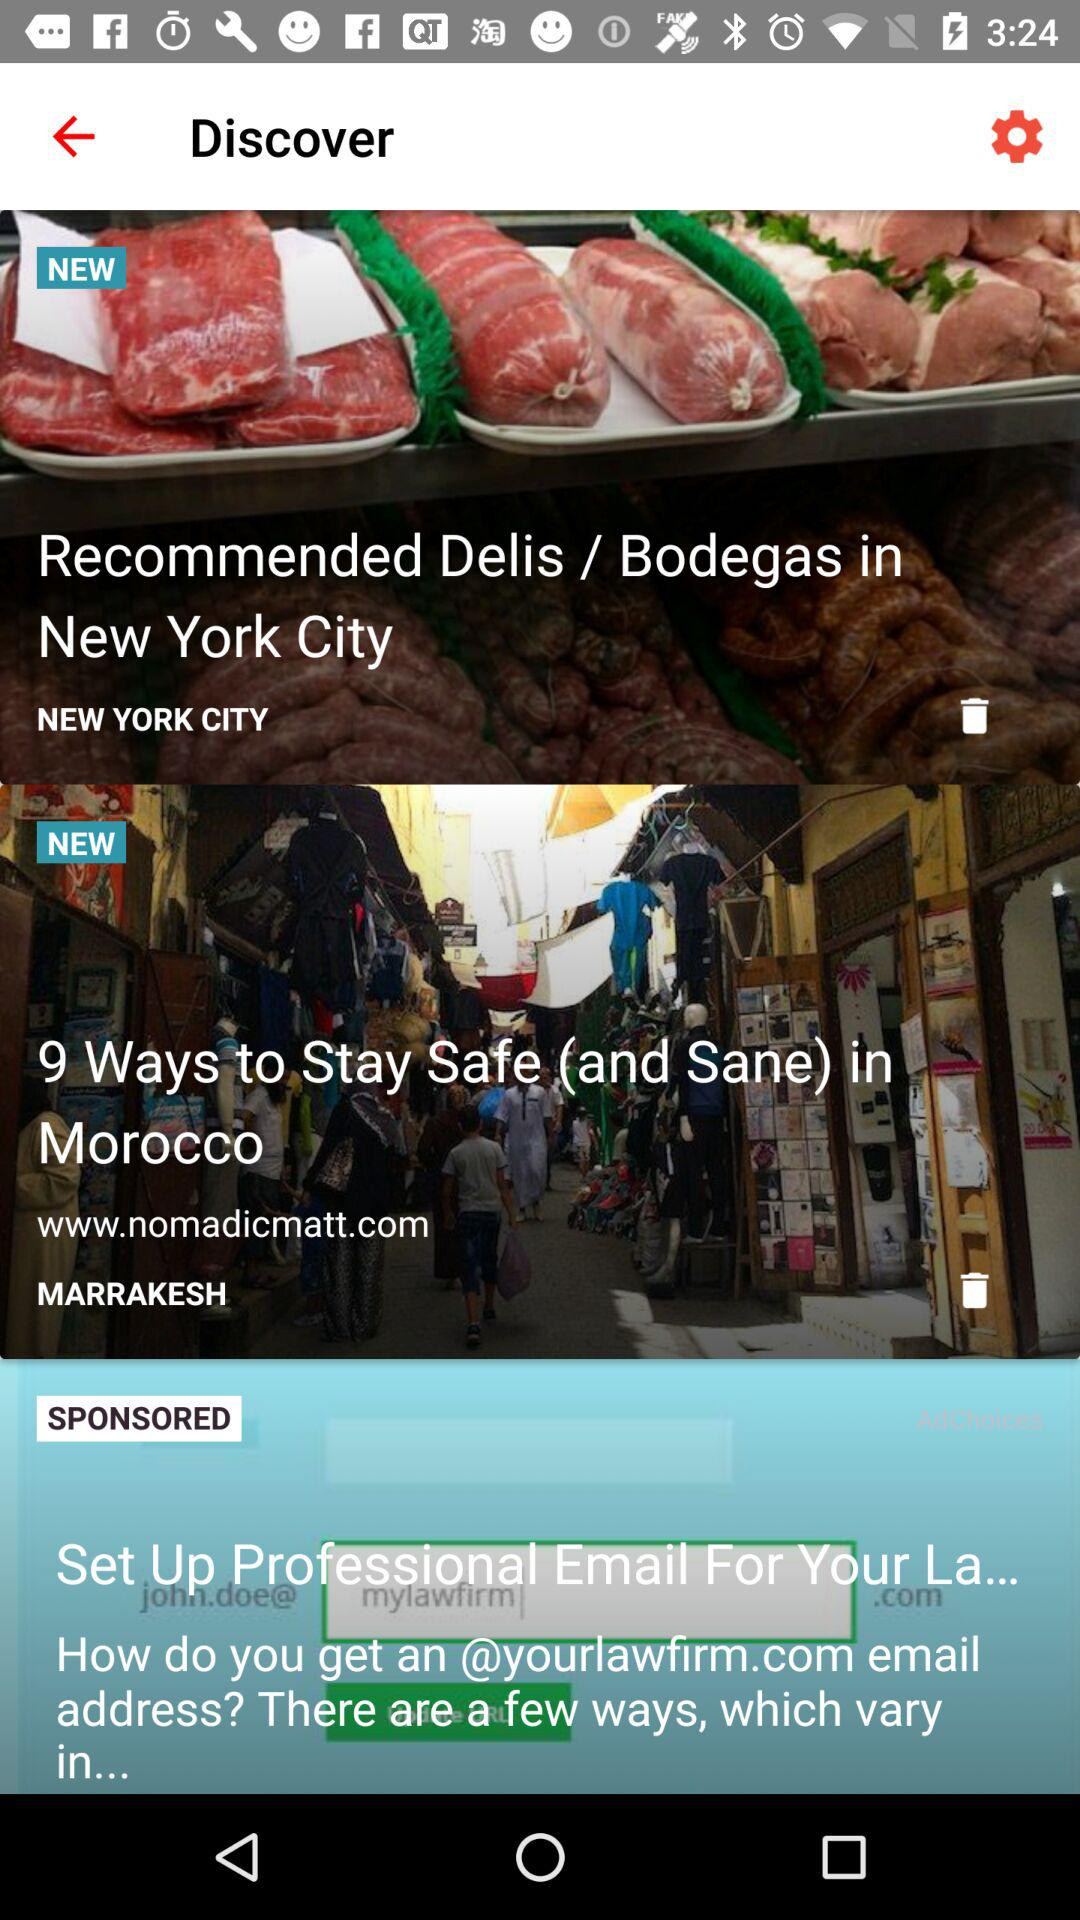In which city do you recommend Delis/Bodegas? Delis/Bodegas is recommended in New York City. 